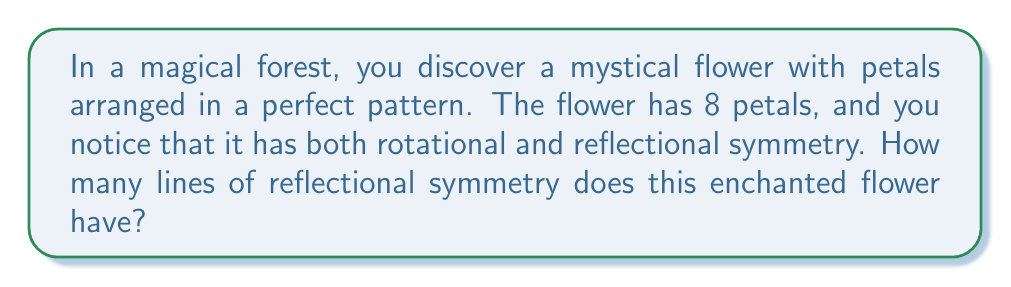Can you answer this question? Let's approach this step-by-step:

1) First, we need to understand what rotational and reflectional symmetry mean:
   - Rotational symmetry: The flower looks the same after being rotated by a certain angle.
   - Reflectional symmetry: The flower can be divided into identical halves by a line.

2) For a regular 8-petaled flower:
   - It has 8-fold rotational symmetry (it looks the same every 45° rotation).
   - The number of lines of reflectional symmetry in a regular polygon is equal to the number of sides (or vertices).

3) To visualize this, let's draw the flower:

   [asy]
   unitsize(2cm);
   for(int i=0; i<8; i++) {
     draw((cos(pi/4*i),sin(pi/4*i))--(0.5*cos(pi/4*i),0.5*sin(pi/4*i)), blue);
   }
   for(int i=0; i<8; i++) {
     draw((0,0)--(cos(pi/4*i),sin(pi/4*i)), red+dashed);
   }
   [/asy]

4) The red dashed lines represent the lines of reflectional symmetry.

5) We can count 8 lines of symmetry:
   - 4 lines go through opposite petals
   - 4 lines go between adjacent petals

Therefore, this enchanted 8-petaled flower has 8 lines of reflectional symmetry.
Answer: 8 